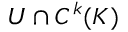Convert formula to latex. <formula><loc_0><loc_0><loc_500><loc_500>U \cap C ^ { k } ( K )</formula> 